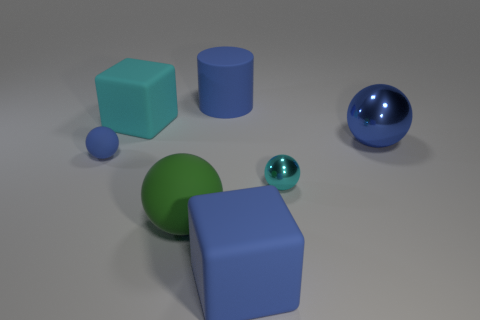What number of large cubes have the same material as the small cyan object?
Keep it short and to the point. 0. How many things are either large spheres that are on the right side of the small cyan shiny object or balls?
Provide a short and direct response. 4. Are there fewer tiny blue rubber things that are on the right side of the blue cylinder than matte blocks that are on the right side of the big green sphere?
Make the answer very short. Yes. Are there any large blue rubber things in front of the blue rubber cylinder?
Offer a very short reply. Yes. How many objects are cyan objects left of the big blue cylinder or rubber cubes right of the blue matte cylinder?
Make the answer very short. 2. What number of tiny rubber spheres are the same color as the rubber cylinder?
Keep it short and to the point. 1. The big matte object that is the same shape as the tiny cyan metal thing is what color?
Your answer should be very brief. Green. There is a big blue thing that is behind the tiny blue object and in front of the cyan rubber cube; what is its shape?
Provide a succinct answer. Sphere. Is the number of tiny things greater than the number of large blue things?
Make the answer very short. No. What is the material of the big blue cylinder?
Provide a succinct answer. Rubber. 